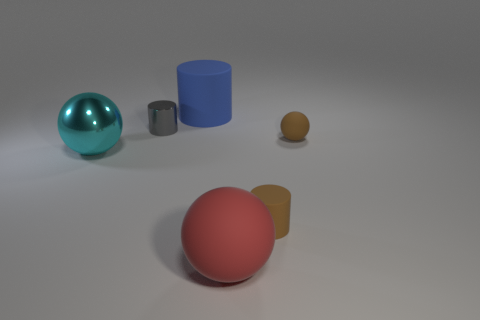Subtract 1 cylinders. How many cylinders are left? 2 Subtract all rubber spheres. How many spheres are left? 1 Add 3 red things. How many objects exist? 9 Subtract 0 green cubes. How many objects are left? 6 Subtract all big red matte things. Subtract all brown balls. How many objects are left? 4 Add 6 small matte cylinders. How many small matte cylinders are left? 7 Add 4 yellow metal spheres. How many yellow metal spheres exist? 4 